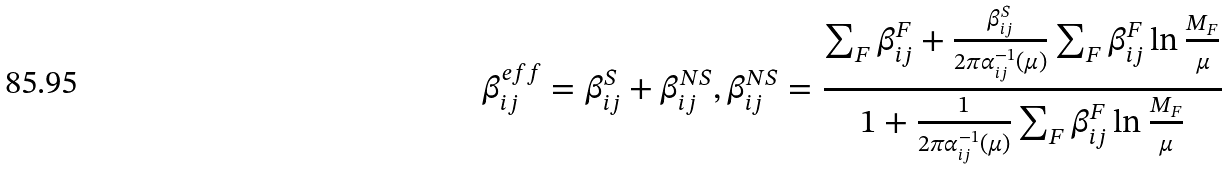Convert formula to latex. <formula><loc_0><loc_0><loc_500><loc_500>\beta _ { i j } ^ { e f f } = \beta _ { i j } ^ { S } + \beta _ { i j } ^ { N S } , \beta _ { i j } ^ { N S } = \frac { \sum _ { F } \beta _ { i j } ^ { F } + \frac { \beta _ { i j } ^ { S } } { 2 \pi \alpha _ { i j } ^ { - 1 } ( \mu ) } \sum _ { F } \beta _ { i j } ^ { F } \ln \frac { M _ { F } } { \mu } } { 1 + \frac { 1 } { 2 \pi \alpha _ { i j } ^ { - 1 } ( \mu ) } \sum _ { F } \beta _ { i j } ^ { F } \ln \frac { M _ { F } } { \mu } }</formula> 